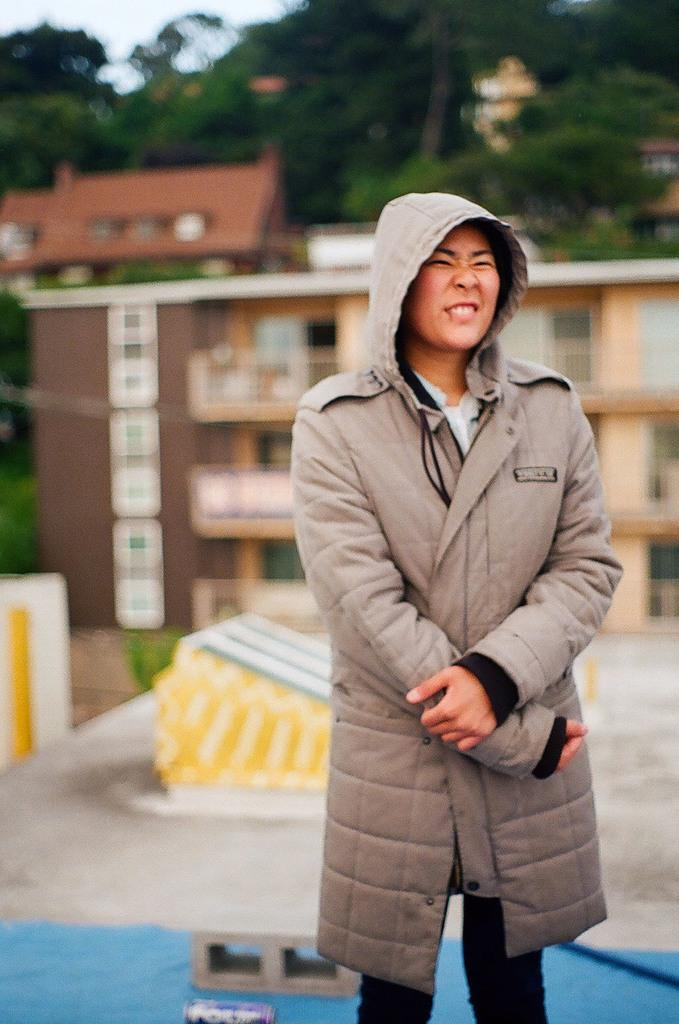What is the main subject in the foreground of the image? There is a person standing on the road in the foreground. What can be seen in the background of the image? There is a houseplant, buildings, trees, and the sky visible in the background. Can you describe the time of day when the image was taken? The image appears to be taken during the day. What type of furniture is being used by the fish in the image? There are no fish or furniture present in the image. 